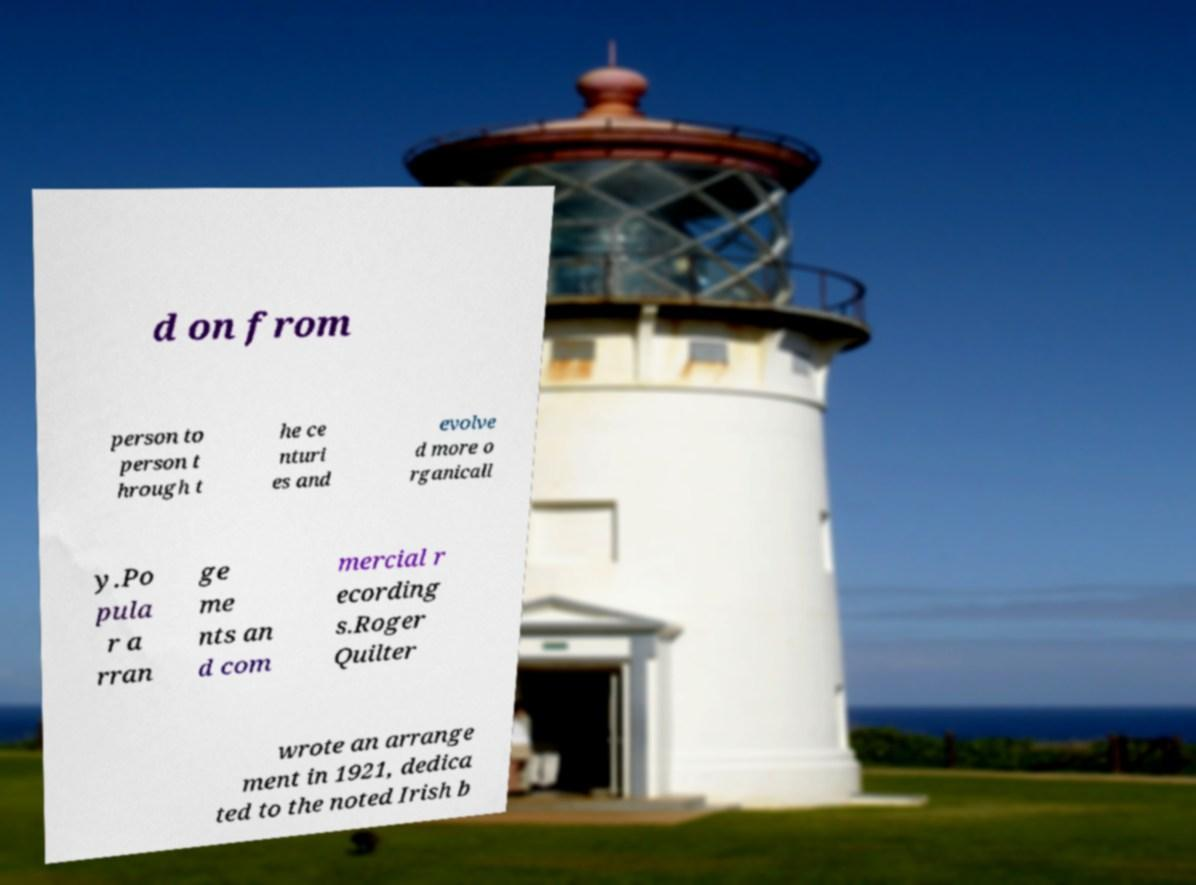There's text embedded in this image that I need extracted. Can you transcribe it verbatim? d on from person to person t hrough t he ce nturi es and evolve d more o rganicall y.Po pula r a rran ge me nts an d com mercial r ecording s.Roger Quilter wrote an arrange ment in 1921, dedica ted to the noted Irish b 